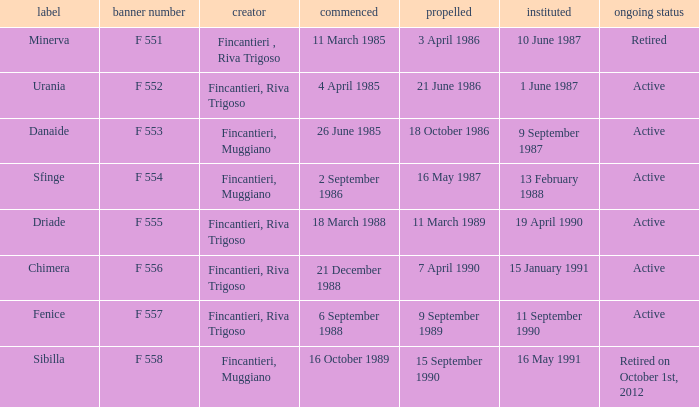What builder is now retired F 551. Can you give me this table as a dict? {'header': ['label', 'banner number', 'creator', 'commenced', 'propelled', 'instituted', 'ongoing status'], 'rows': [['Minerva', 'F 551', 'Fincantieri , Riva Trigoso', '11 March 1985', '3 April 1986', '10 June 1987', 'Retired'], ['Urania', 'F 552', 'Fincantieri, Riva Trigoso', '4 April 1985', '21 June 1986', '1 June 1987', 'Active'], ['Danaide', 'F 553', 'Fincantieri, Muggiano', '26 June 1985', '18 October 1986', '9 September 1987', 'Active'], ['Sfinge', 'F 554', 'Fincantieri, Muggiano', '2 September 1986', '16 May 1987', '13 February 1988', 'Active'], ['Driade', 'F 555', 'Fincantieri, Riva Trigoso', '18 March 1988', '11 March 1989', '19 April 1990', 'Active'], ['Chimera', 'F 556', 'Fincantieri, Riva Trigoso', '21 December 1988', '7 April 1990', '15 January 1991', 'Active'], ['Fenice', 'F 557', 'Fincantieri, Riva Trigoso', '6 September 1988', '9 September 1989', '11 September 1990', 'Active'], ['Sibilla', 'F 558', 'Fincantieri, Muggiano', '16 October 1989', '15 September 1990', '16 May 1991', 'Retired on October 1st, 2012']]} 